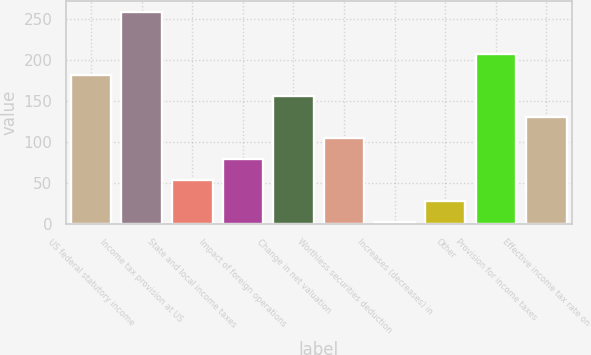<chart> <loc_0><loc_0><loc_500><loc_500><bar_chart><fcel>US federal statutory income<fcel>Income tax provision at US<fcel>State and local income taxes<fcel>Impact of foreign operations<fcel>Change in net valuation<fcel>Worthless securities deduction<fcel>Increases (decreases) in<fcel>Other<fcel>Provision for income taxes<fcel>Effective income tax rate on<nl><fcel>181.69<fcel>258.4<fcel>53.84<fcel>79.41<fcel>156.12<fcel>104.98<fcel>2.7<fcel>28.27<fcel>207.26<fcel>130.55<nl></chart> 